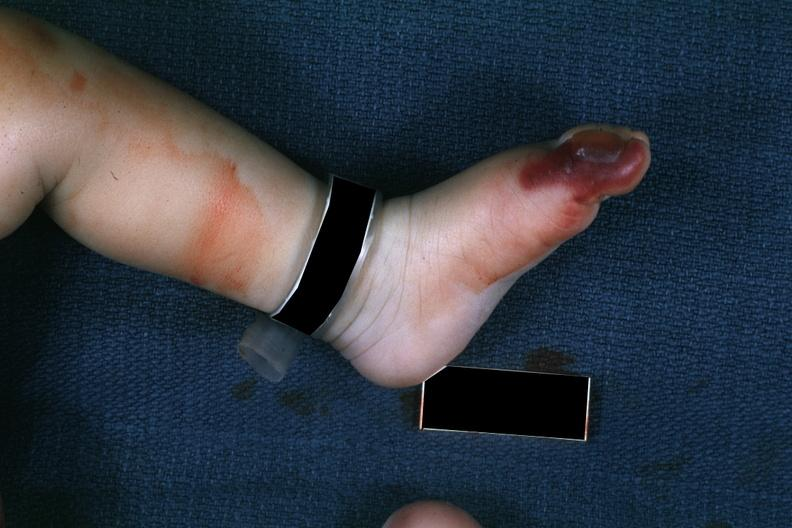s gangrene toe in infant present?
Answer the question using a single word or phrase. Yes 